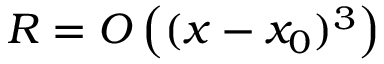Convert formula to latex. <formula><loc_0><loc_0><loc_500><loc_500>R = O \left ( ( x - x _ { 0 } ) ^ { 3 } \right )</formula> 